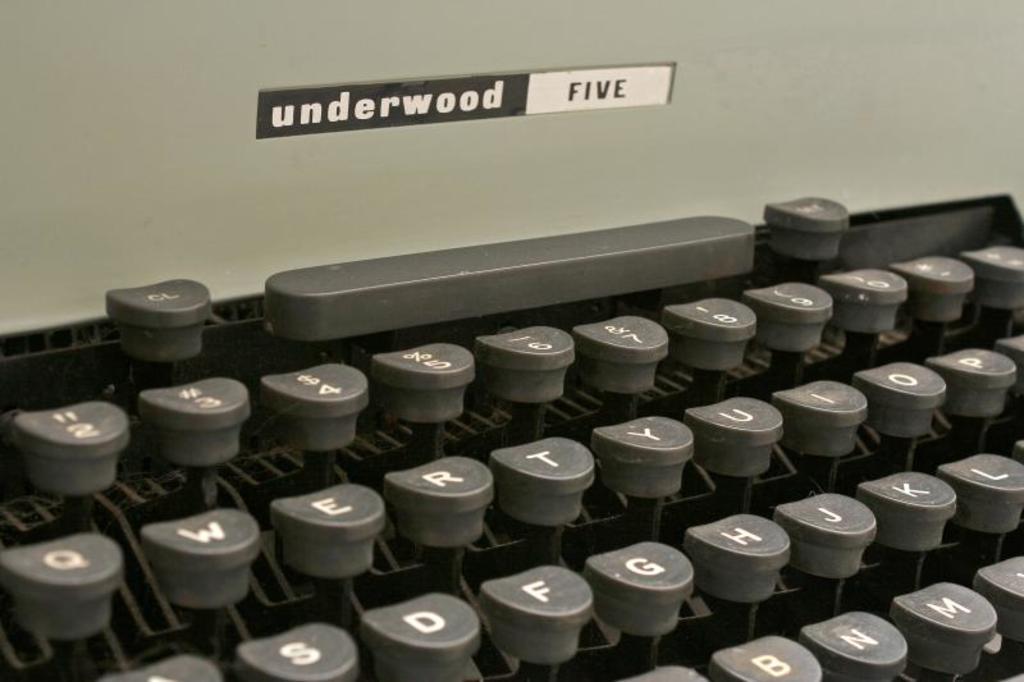What type of typewriter is this?
Give a very brief answer. Underwood five. What model of typewriter is this?
Your answer should be very brief. Underwood five. 